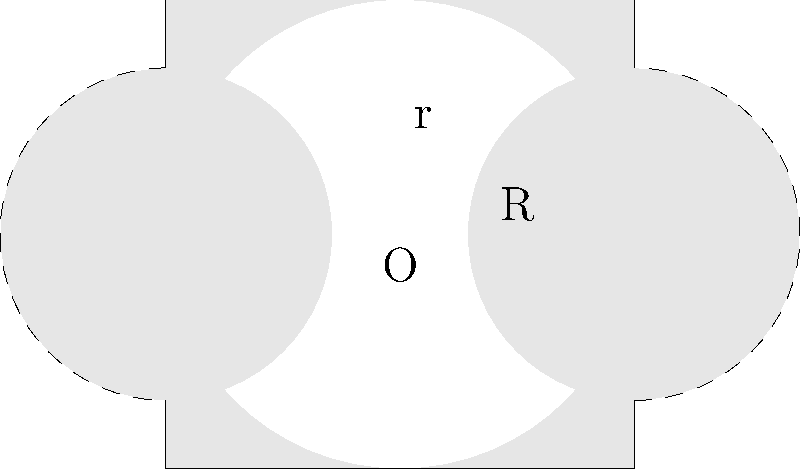In the figure above, a square with side length 4 units contains a circle centered at O with radius $r = 2$ units. Two smaller circles with centers at $(2,0)$ and $(-2,0)$ have radii $R = \sqrt{2}$ units. Calculate the area of the shaded region. Let's approach this step-by-step:

1) Area of the square: $A_{square} = 4^2 = 16$ square units

2) Area of the large circle: $A_{large} = \pi r^2 = \pi (2^2) = 4\pi$ square units

3) Area of each small circle: $A_{small} = \pi R^2 = \pi (\sqrt{2}^2) = 2\pi$ square units

4) The shaded area is the area of the square minus the area of the large circle plus the areas of the parts of the small circles that are outside the large circle.

5) The area of each small circle outside the large circle is half of its total area:
   $A_{outside} = \frac{1}{2} A_{small} = \pi$ square units

6) There are two such areas, so the total area to add back is $2\pi$ square units

7) Therefore, the shaded area is:
   $A_{shaded} = A_{square} - A_{large} + 2A_{outside}$
   $A_{shaded} = 16 - 4\pi + 2\pi = 16 - 2\pi$ square units

This problem combines concepts from geometry that are relevant to both medicine (e.g., circular cell structures) and engineering (e.g., overlapping fields in sensor design), making it an interesting challenge for students considering both career paths.
Answer: $16 - 2\pi$ square units 